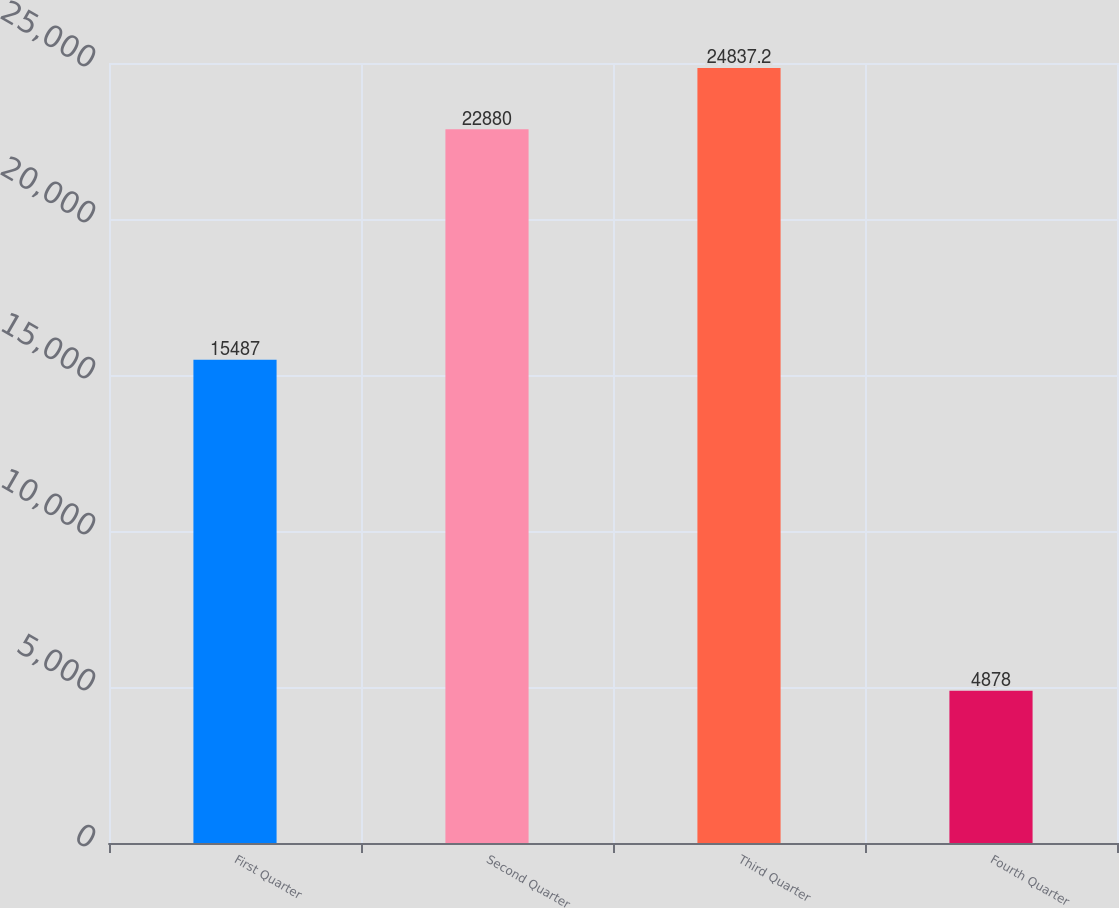Convert chart to OTSL. <chart><loc_0><loc_0><loc_500><loc_500><bar_chart><fcel>First Quarter<fcel>Second Quarter<fcel>Third Quarter<fcel>Fourth Quarter<nl><fcel>15487<fcel>22880<fcel>24837.2<fcel>4878<nl></chart> 